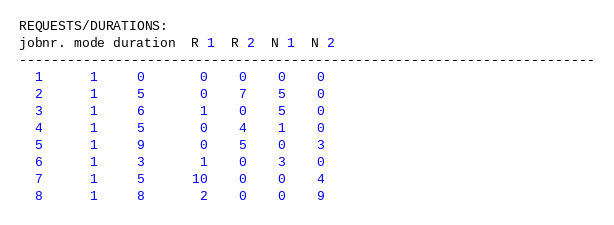<code> <loc_0><loc_0><loc_500><loc_500><_ObjectiveC_>REQUESTS/DURATIONS:
jobnr. mode duration  R 1  R 2  N 1  N 2
------------------------------------------------------------------------
  1      1     0       0    0    0    0
  2      1     5       0    7    5    0
  3      1     6       1    0    5    0
  4      1     5       0    4    1    0
  5      1     9       0    5    0    3
  6      1     3       1    0    3    0
  7      1     5      10    0    0    4
  8      1     8       2    0    0    9</code> 